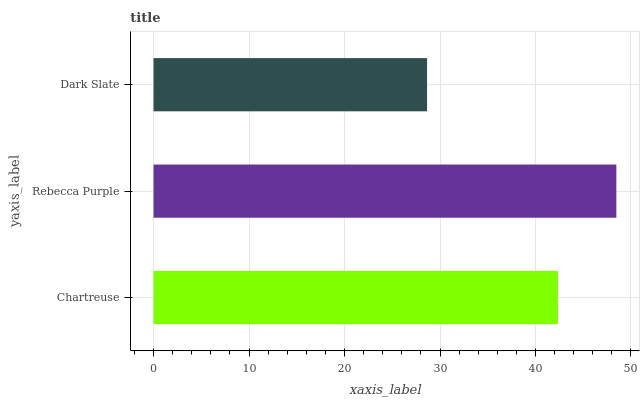Is Dark Slate the minimum?
Answer yes or no. Yes. Is Rebecca Purple the maximum?
Answer yes or no. Yes. Is Rebecca Purple the minimum?
Answer yes or no. No. Is Dark Slate the maximum?
Answer yes or no. No. Is Rebecca Purple greater than Dark Slate?
Answer yes or no. Yes. Is Dark Slate less than Rebecca Purple?
Answer yes or no. Yes. Is Dark Slate greater than Rebecca Purple?
Answer yes or no. No. Is Rebecca Purple less than Dark Slate?
Answer yes or no. No. Is Chartreuse the high median?
Answer yes or no. Yes. Is Chartreuse the low median?
Answer yes or no. Yes. Is Rebecca Purple the high median?
Answer yes or no. No. Is Dark Slate the low median?
Answer yes or no. No. 